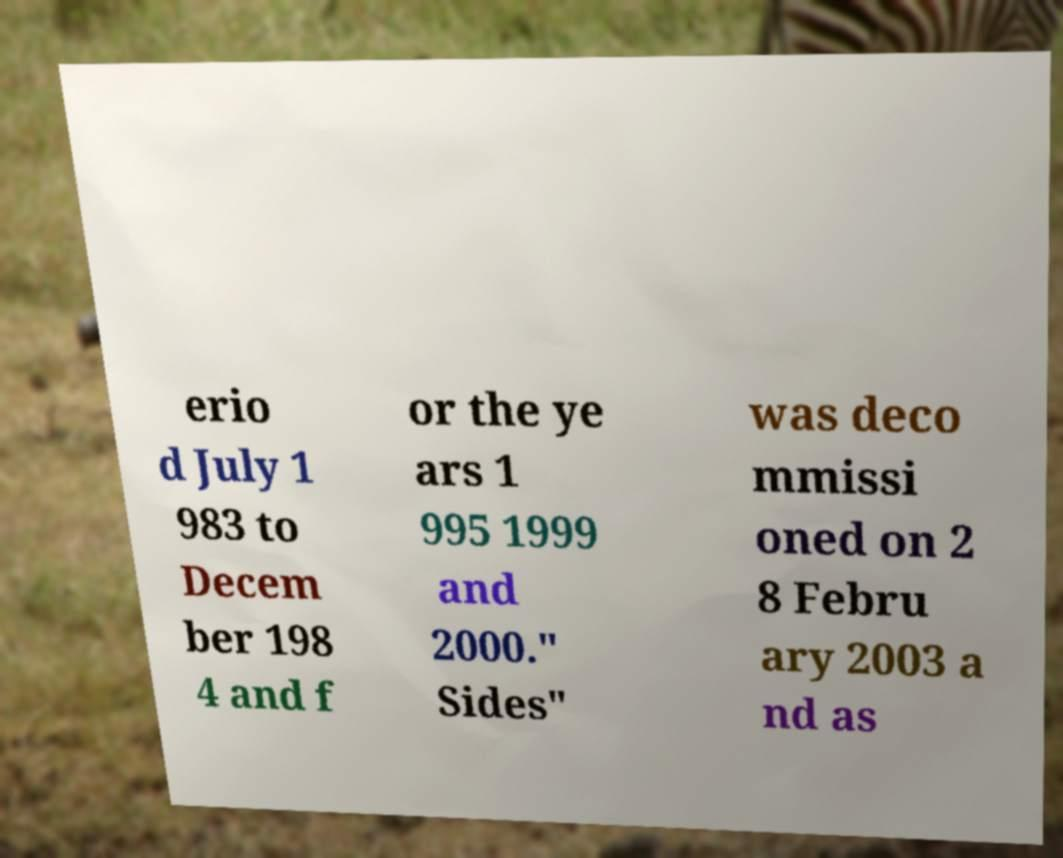Can you accurately transcribe the text from the provided image for me? erio d July 1 983 to Decem ber 198 4 and f or the ye ars 1 995 1999 and 2000." Sides" was deco mmissi oned on 2 8 Febru ary 2003 a nd as 